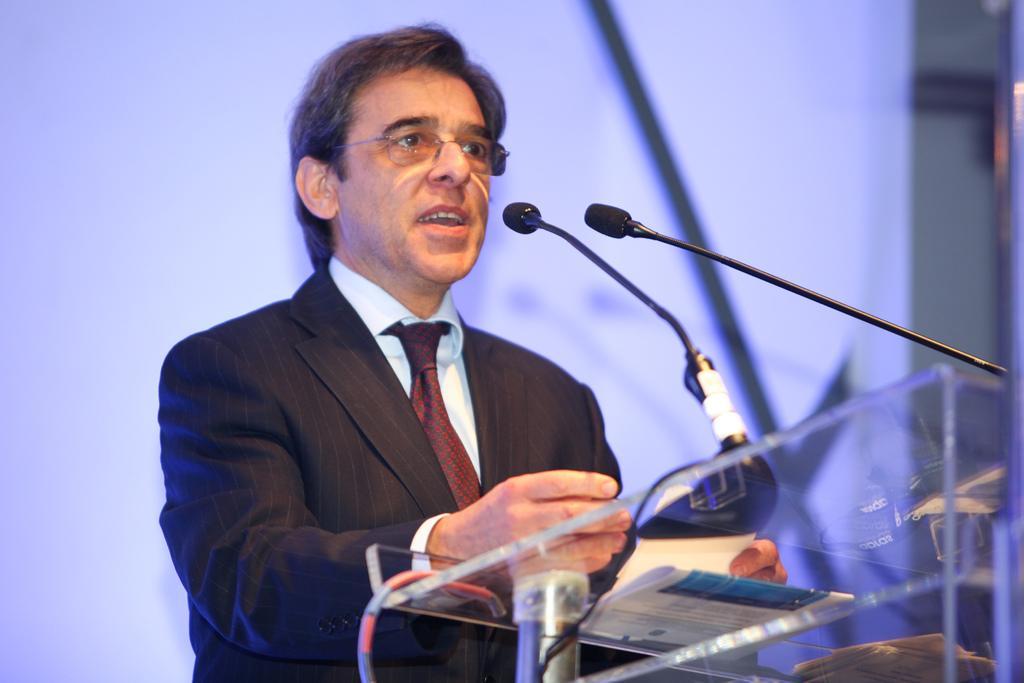Describe this image in one or two sentences. In this picture we can see a man wearing spectacles, blazer, white shirt and a tie, standing near to a podium. On the podium we can see mice and paper. 